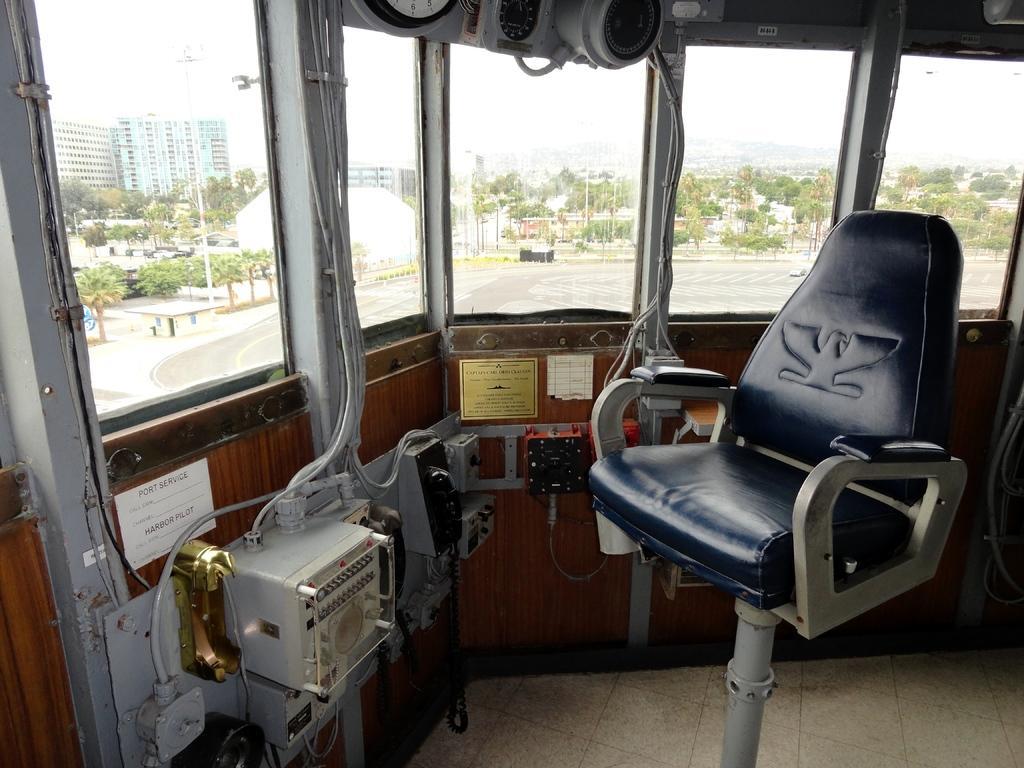In one or two sentences, can you explain what this image depicts? In the middle of the picture, we see a chair and machinery equipment. Here, we see windows from which we can see road, trees, poles and buildings. We even see the sky. 